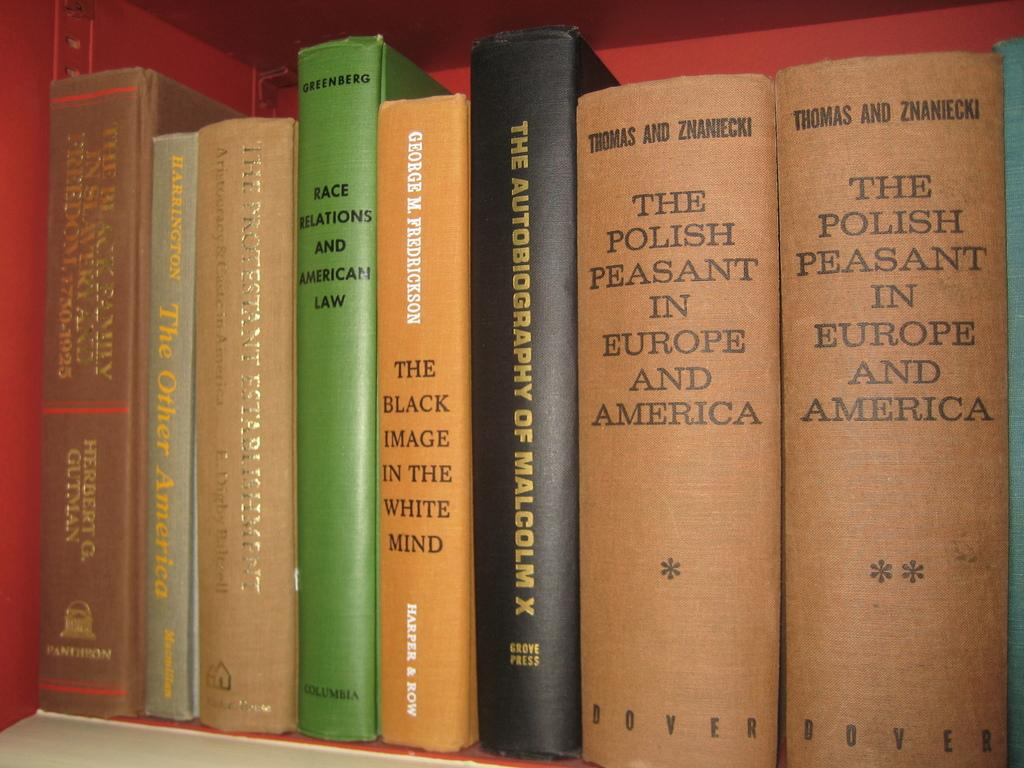<image>
Relay a brief, clear account of the picture shown. A row of books including two copies of The Polish Peasant in Europe and America. 